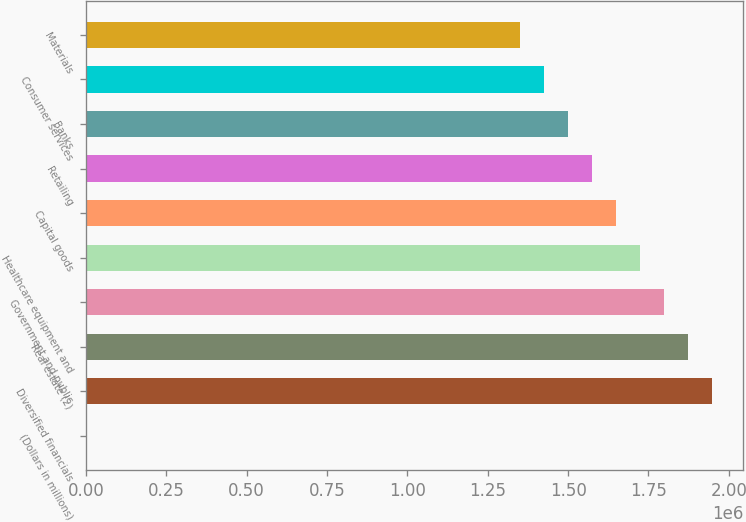Convert chart to OTSL. <chart><loc_0><loc_0><loc_500><loc_500><bar_chart><fcel>(Dollars in millions)<fcel>Diversified financials<fcel>Real estate (2)<fcel>Government and public<fcel>Healthcare equipment and<fcel>Capital goods<fcel>Retailing<fcel>Banks<fcel>Consumer services<fcel>Materials<nl><fcel>2011<fcel>1.94817e+06<fcel>1.87331e+06<fcel>1.79846e+06<fcel>1.72361e+06<fcel>1.64876e+06<fcel>1.57391e+06<fcel>1.49905e+06<fcel>1.4242e+06<fcel>1.34935e+06<nl></chart> 